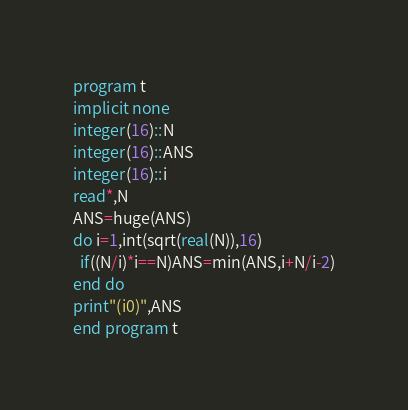<code> <loc_0><loc_0><loc_500><loc_500><_FORTRAN_>program t
implicit none
integer(16)::N
integer(16)::ANS
integer(16)::i
read*,N
ANS=huge(ANS)
do i=1,int(sqrt(real(N)),16)
  if((N/i)*i==N)ANS=min(ANS,i+N/i-2)
end do
print"(i0)",ANS
end program t</code> 